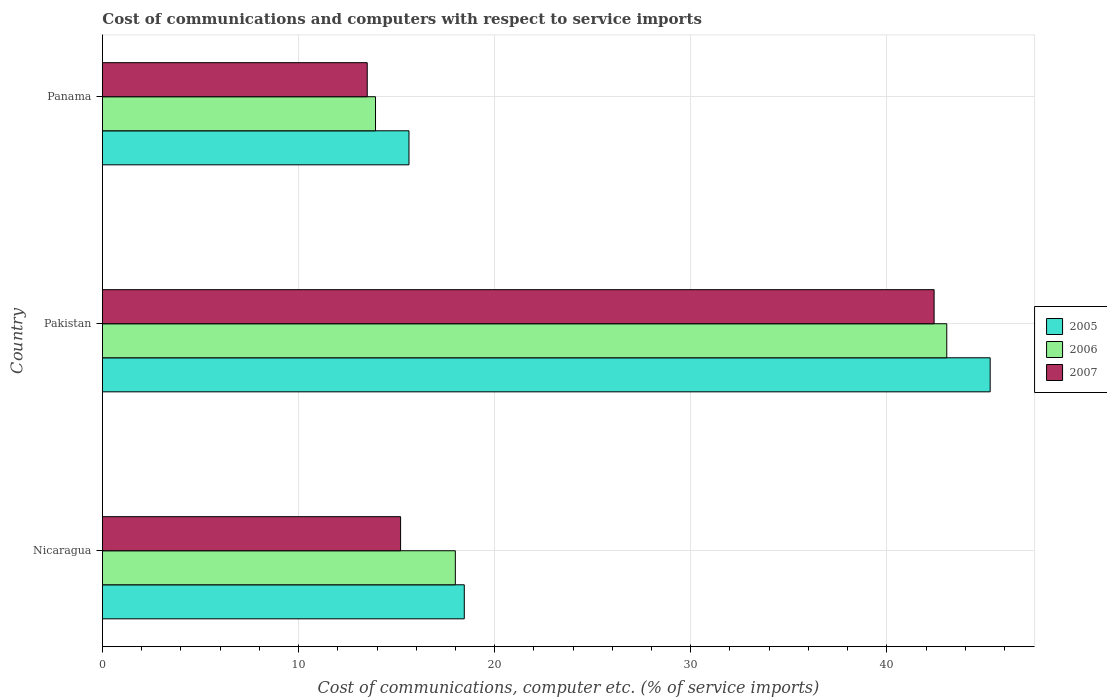How many different coloured bars are there?
Keep it short and to the point. 3. Are the number of bars per tick equal to the number of legend labels?
Your answer should be very brief. Yes. Are the number of bars on each tick of the Y-axis equal?
Provide a short and direct response. Yes. How many bars are there on the 1st tick from the top?
Keep it short and to the point. 3. What is the label of the 3rd group of bars from the top?
Keep it short and to the point. Nicaragua. In how many cases, is the number of bars for a given country not equal to the number of legend labels?
Ensure brevity in your answer.  0. What is the cost of communications and computers in 2005 in Nicaragua?
Your answer should be very brief. 18.45. Across all countries, what is the maximum cost of communications and computers in 2007?
Provide a short and direct response. 42.41. Across all countries, what is the minimum cost of communications and computers in 2006?
Make the answer very short. 13.92. In which country was the cost of communications and computers in 2005 minimum?
Make the answer very short. Panama. What is the total cost of communications and computers in 2007 in the graph?
Make the answer very short. 71.12. What is the difference between the cost of communications and computers in 2007 in Nicaragua and that in Pakistan?
Your answer should be compact. -27.21. What is the difference between the cost of communications and computers in 2006 in Nicaragua and the cost of communications and computers in 2005 in Panama?
Make the answer very short. 2.36. What is the average cost of communications and computers in 2005 per country?
Give a very brief answer. 26.45. What is the difference between the cost of communications and computers in 2006 and cost of communications and computers in 2007 in Panama?
Keep it short and to the point. 0.42. In how many countries, is the cost of communications and computers in 2005 greater than 32 %?
Your answer should be very brief. 1. What is the ratio of the cost of communications and computers in 2005 in Nicaragua to that in Pakistan?
Make the answer very short. 0.41. Is the cost of communications and computers in 2007 in Pakistan less than that in Panama?
Ensure brevity in your answer.  No. What is the difference between the highest and the second highest cost of communications and computers in 2007?
Make the answer very short. 27.21. What is the difference between the highest and the lowest cost of communications and computers in 2005?
Your response must be concise. 29.64. Is the sum of the cost of communications and computers in 2006 in Pakistan and Panama greater than the maximum cost of communications and computers in 2005 across all countries?
Offer a very short reply. Yes. What does the 1st bar from the top in Pakistan represents?
Your answer should be very brief. 2007. What is the difference between two consecutive major ticks on the X-axis?
Provide a succinct answer. 10. Are the values on the major ticks of X-axis written in scientific E-notation?
Offer a very short reply. No. Does the graph contain any zero values?
Keep it short and to the point. No. Where does the legend appear in the graph?
Make the answer very short. Center right. What is the title of the graph?
Provide a short and direct response. Cost of communications and computers with respect to service imports. Does "1992" appear as one of the legend labels in the graph?
Keep it short and to the point. No. What is the label or title of the X-axis?
Your answer should be very brief. Cost of communications, computer etc. (% of service imports). What is the Cost of communications, computer etc. (% of service imports) of 2005 in Nicaragua?
Your response must be concise. 18.45. What is the Cost of communications, computer etc. (% of service imports) in 2006 in Nicaragua?
Offer a terse response. 18. What is the Cost of communications, computer etc. (% of service imports) in 2007 in Nicaragua?
Offer a very short reply. 15.2. What is the Cost of communications, computer etc. (% of service imports) in 2005 in Pakistan?
Your answer should be compact. 45.27. What is the Cost of communications, computer etc. (% of service imports) in 2006 in Pakistan?
Offer a terse response. 43.06. What is the Cost of communications, computer etc. (% of service imports) in 2007 in Pakistan?
Ensure brevity in your answer.  42.41. What is the Cost of communications, computer etc. (% of service imports) of 2005 in Panama?
Your answer should be very brief. 15.63. What is the Cost of communications, computer etc. (% of service imports) of 2006 in Panama?
Offer a terse response. 13.92. What is the Cost of communications, computer etc. (% of service imports) in 2007 in Panama?
Make the answer very short. 13.5. Across all countries, what is the maximum Cost of communications, computer etc. (% of service imports) in 2005?
Make the answer very short. 45.27. Across all countries, what is the maximum Cost of communications, computer etc. (% of service imports) of 2006?
Give a very brief answer. 43.06. Across all countries, what is the maximum Cost of communications, computer etc. (% of service imports) of 2007?
Keep it short and to the point. 42.41. Across all countries, what is the minimum Cost of communications, computer etc. (% of service imports) of 2005?
Make the answer very short. 15.63. Across all countries, what is the minimum Cost of communications, computer etc. (% of service imports) in 2006?
Offer a very short reply. 13.92. Across all countries, what is the minimum Cost of communications, computer etc. (% of service imports) of 2007?
Keep it short and to the point. 13.5. What is the total Cost of communications, computer etc. (% of service imports) in 2005 in the graph?
Your answer should be compact. 79.35. What is the total Cost of communications, computer etc. (% of service imports) of 2006 in the graph?
Ensure brevity in your answer.  74.98. What is the total Cost of communications, computer etc. (% of service imports) in 2007 in the graph?
Make the answer very short. 71.12. What is the difference between the Cost of communications, computer etc. (% of service imports) in 2005 in Nicaragua and that in Pakistan?
Your response must be concise. -26.82. What is the difference between the Cost of communications, computer etc. (% of service imports) of 2006 in Nicaragua and that in Pakistan?
Offer a very short reply. -25.06. What is the difference between the Cost of communications, computer etc. (% of service imports) in 2007 in Nicaragua and that in Pakistan?
Your answer should be very brief. -27.21. What is the difference between the Cost of communications, computer etc. (% of service imports) in 2005 in Nicaragua and that in Panama?
Give a very brief answer. 2.82. What is the difference between the Cost of communications, computer etc. (% of service imports) in 2006 in Nicaragua and that in Panama?
Provide a succinct answer. 4.07. What is the difference between the Cost of communications, computer etc. (% of service imports) of 2007 in Nicaragua and that in Panama?
Your answer should be compact. 1.7. What is the difference between the Cost of communications, computer etc. (% of service imports) in 2005 in Pakistan and that in Panama?
Ensure brevity in your answer.  29.64. What is the difference between the Cost of communications, computer etc. (% of service imports) in 2006 in Pakistan and that in Panama?
Your response must be concise. 29.13. What is the difference between the Cost of communications, computer etc. (% of service imports) in 2007 in Pakistan and that in Panama?
Keep it short and to the point. 28.91. What is the difference between the Cost of communications, computer etc. (% of service imports) of 2005 in Nicaragua and the Cost of communications, computer etc. (% of service imports) of 2006 in Pakistan?
Keep it short and to the point. -24.61. What is the difference between the Cost of communications, computer etc. (% of service imports) in 2005 in Nicaragua and the Cost of communications, computer etc. (% of service imports) in 2007 in Pakistan?
Ensure brevity in your answer.  -23.96. What is the difference between the Cost of communications, computer etc. (% of service imports) of 2006 in Nicaragua and the Cost of communications, computer etc. (% of service imports) of 2007 in Pakistan?
Your answer should be compact. -24.42. What is the difference between the Cost of communications, computer etc. (% of service imports) of 2005 in Nicaragua and the Cost of communications, computer etc. (% of service imports) of 2006 in Panama?
Ensure brevity in your answer.  4.53. What is the difference between the Cost of communications, computer etc. (% of service imports) of 2005 in Nicaragua and the Cost of communications, computer etc. (% of service imports) of 2007 in Panama?
Your response must be concise. 4.95. What is the difference between the Cost of communications, computer etc. (% of service imports) in 2006 in Nicaragua and the Cost of communications, computer etc. (% of service imports) in 2007 in Panama?
Make the answer very short. 4.49. What is the difference between the Cost of communications, computer etc. (% of service imports) in 2005 in Pakistan and the Cost of communications, computer etc. (% of service imports) in 2006 in Panama?
Keep it short and to the point. 31.35. What is the difference between the Cost of communications, computer etc. (% of service imports) of 2005 in Pakistan and the Cost of communications, computer etc. (% of service imports) of 2007 in Panama?
Provide a short and direct response. 31.77. What is the difference between the Cost of communications, computer etc. (% of service imports) of 2006 in Pakistan and the Cost of communications, computer etc. (% of service imports) of 2007 in Panama?
Ensure brevity in your answer.  29.55. What is the average Cost of communications, computer etc. (% of service imports) in 2005 per country?
Offer a very short reply. 26.45. What is the average Cost of communications, computer etc. (% of service imports) in 2006 per country?
Provide a succinct answer. 24.99. What is the average Cost of communications, computer etc. (% of service imports) of 2007 per country?
Offer a terse response. 23.71. What is the difference between the Cost of communications, computer etc. (% of service imports) of 2005 and Cost of communications, computer etc. (% of service imports) of 2006 in Nicaragua?
Ensure brevity in your answer.  0.46. What is the difference between the Cost of communications, computer etc. (% of service imports) of 2005 and Cost of communications, computer etc. (% of service imports) of 2007 in Nicaragua?
Give a very brief answer. 3.25. What is the difference between the Cost of communications, computer etc. (% of service imports) of 2006 and Cost of communications, computer etc. (% of service imports) of 2007 in Nicaragua?
Provide a short and direct response. 2.79. What is the difference between the Cost of communications, computer etc. (% of service imports) in 2005 and Cost of communications, computer etc. (% of service imports) in 2006 in Pakistan?
Your response must be concise. 2.21. What is the difference between the Cost of communications, computer etc. (% of service imports) of 2005 and Cost of communications, computer etc. (% of service imports) of 2007 in Pakistan?
Ensure brevity in your answer.  2.86. What is the difference between the Cost of communications, computer etc. (% of service imports) in 2006 and Cost of communications, computer etc. (% of service imports) in 2007 in Pakistan?
Your answer should be compact. 0.65. What is the difference between the Cost of communications, computer etc. (% of service imports) of 2005 and Cost of communications, computer etc. (% of service imports) of 2006 in Panama?
Your answer should be compact. 1.71. What is the difference between the Cost of communications, computer etc. (% of service imports) of 2005 and Cost of communications, computer etc. (% of service imports) of 2007 in Panama?
Ensure brevity in your answer.  2.13. What is the difference between the Cost of communications, computer etc. (% of service imports) of 2006 and Cost of communications, computer etc. (% of service imports) of 2007 in Panama?
Provide a short and direct response. 0.42. What is the ratio of the Cost of communications, computer etc. (% of service imports) in 2005 in Nicaragua to that in Pakistan?
Offer a very short reply. 0.41. What is the ratio of the Cost of communications, computer etc. (% of service imports) of 2006 in Nicaragua to that in Pakistan?
Offer a very short reply. 0.42. What is the ratio of the Cost of communications, computer etc. (% of service imports) of 2007 in Nicaragua to that in Pakistan?
Offer a very short reply. 0.36. What is the ratio of the Cost of communications, computer etc. (% of service imports) of 2005 in Nicaragua to that in Panama?
Offer a very short reply. 1.18. What is the ratio of the Cost of communications, computer etc. (% of service imports) of 2006 in Nicaragua to that in Panama?
Ensure brevity in your answer.  1.29. What is the ratio of the Cost of communications, computer etc. (% of service imports) of 2007 in Nicaragua to that in Panama?
Your answer should be compact. 1.13. What is the ratio of the Cost of communications, computer etc. (% of service imports) in 2005 in Pakistan to that in Panama?
Offer a terse response. 2.9. What is the ratio of the Cost of communications, computer etc. (% of service imports) of 2006 in Pakistan to that in Panama?
Provide a short and direct response. 3.09. What is the ratio of the Cost of communications, computer etc. (% of service imports) of 2007 in Pakistan to that in Panama?
Provide a short and direct response. 3.14. What is the difference between the highest and the second highest Cost of communications, computer etc. (% of service imports) in 2005?
Provide a succinct answer. 26.82. What is the difference between the highest and the second highest Cost of communications, computer etc. (% of service imports) in 2006?
Keep it short and to the point. 25.06. What is the difference between the highest and the second highest Cost of communications, computer etc. (% of service imports) in 2007?
Your response must be concise. 27.21. What is the difference between the highest and the lowest Cost of communications, computer etc. (% of service imports) of 2005?
Ensure brevity in your answer.  29.64. What is the difference between the highest and the lowest Cost of communications, computer etc. (% of service imports) of 2006?
Your answer should be compact. 29.13. What is the difference between the highest and the lowest Cost of communications, computer etc. (% of service imports) in 2007?
Ensure brevity in your answer.  28.91. 